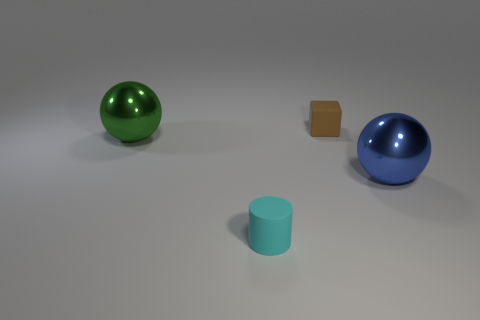Add 2 blue spheres. How many objects exist? 6 Subtract all cylinders. How many objects are left? 3 Add 3 big green shiny spheres. How many big green shiny spheres exist? 4 Subtract 0 yellow balls. How many objects are left? 4 Subtract all big metallic cubes. Subtract all large balls. How many objects are left? 2 Add 1 green things. How many green things are left? 2 